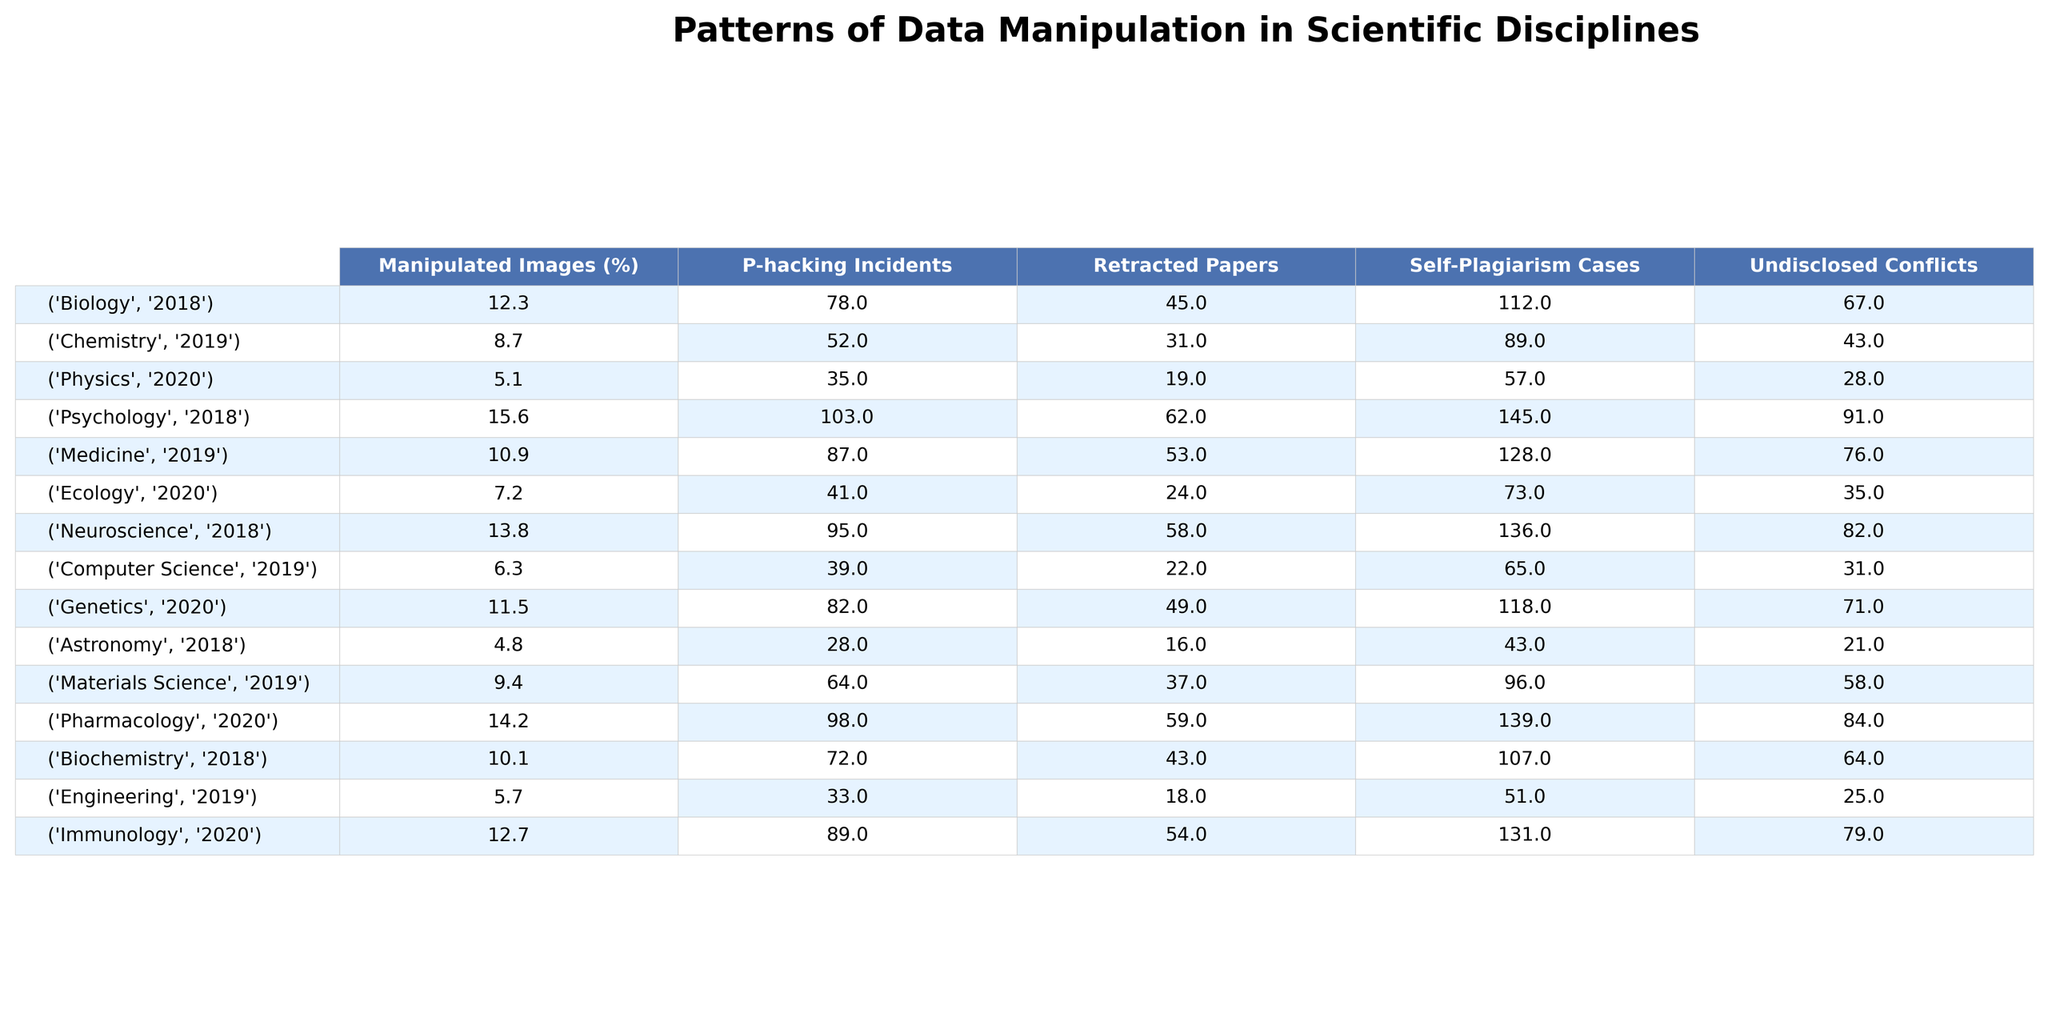What discipline had the highest percentage of manipulated images in 2018? In 2018, the data for manipulated images shows Biology at 12.3% and Psychology at 15.6%, which is the highest percentage of all disciplines listed for that year.
Answer: Psychology How many retracted papers were there in Medicine in 2019? The table indicates that there were 53 retracted papers in Medicine for the year 2019, as it is stated directly in the corresponding cell of the table.
Answer: 53 What is the average percentage of manipulated images across all disciplines listed for 2020? The percentages for 2020 are 5.1% (Physics), 7.2% (Ecology), 11.5% (Genetics), 14.2% (Pharmacology), and 12.7% (Immunology). Summing these gives 50.7%, and dividing by 5 (the number of data points) gives an average of 10.14%.
Answer: 10.14% Is there a discipline with zero reported self-plagiarism cases? The table has entries for all disciplines with reported self-plagiarism cases, including the lowest number at 18 in Engineering. Thus, there is no discipline with zero cases.
Answer: No What is the difference in the number of P-hacking incidents between Psychology and Neuroscience in 2018? In 2018, Psychology reported 103 P-hacking incidents, while Neuroscience reported 95 incidents. The difference is calculated as 103 - 95 = 8.
Answer: 8 Which discipline showed the highest number of undisclosed conflicts in 2018? According to the table, in 2018, Psychology had the highest number of undisclosed conflicts, reported at 91 cases, which is more than any other discipline in the same year.
Answer: Psychology What is the total number of retracted papers from 2019 across Chemistry and Materials Science? Chemistry had 31 retracted papers, and Materials Science had 37. Adding these gives 31 + 37 = 68 retracted papers in total for these two disciplines.
Answer: 68 Which year saw the lowest percentage of manipulated images and in which discipline was it recorded? Reviewing the years and respective manipulated image percentages, Physics in 2020 recorded the lowest at 5.1%.
Answer: Physics, 2020 If you combine the number of retracted papers from Biology and Pharmacology, what total do you get? Biology had 45 retracted papers and Pharmacology had 59. Adding these gives 45 + 59 = 104 retracted papers in total.
Answer: 104 What percentage of manipulated images is reported in Ecology compared to the average across all disciplines for 2020? Ecology reported 7.2% manipulated images; the average calculated for 2020 was 10.14%. Since 7.2% is less than 10.14%, Ecology is below the average.
Answer: Below average 